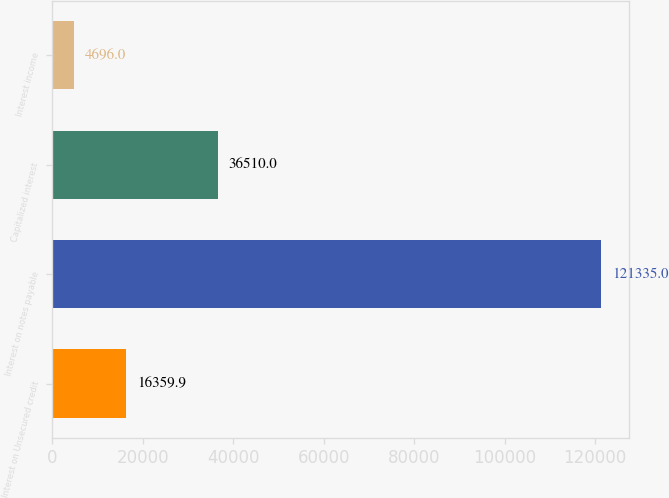Convert chart. <chart><loc_0><loc_0><loc_500><loc_500><bar_chart><fcel>Interest on Unsecured credit<fcel>Interest on notes payable<fcel>Capitalized interest<fcel>Interest income<nl><fcel>16359.9<fcel>121335<fcel>36510<fcel>4696<nl></chart> 